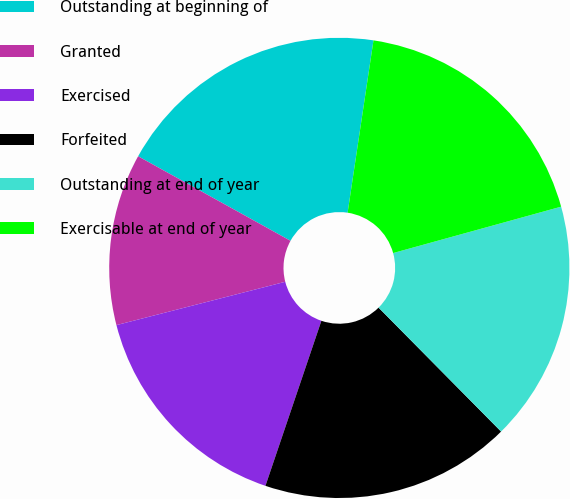<chart> <loc_0><loc_0><loc_500><loc_500><pie_chart><fcel>Outstanding at beginning of<fcel>Granted<fcel>Exercised<fcel>Forfeited<fcel>Outstanding at end of year<fcel>Exercisable at end of year<nl><fcel>19.31%<fcel>12.06%<fcel>15.8%<fcel>17.61%<fcel>16.88%<fcel>18.34%<nl></chart> 